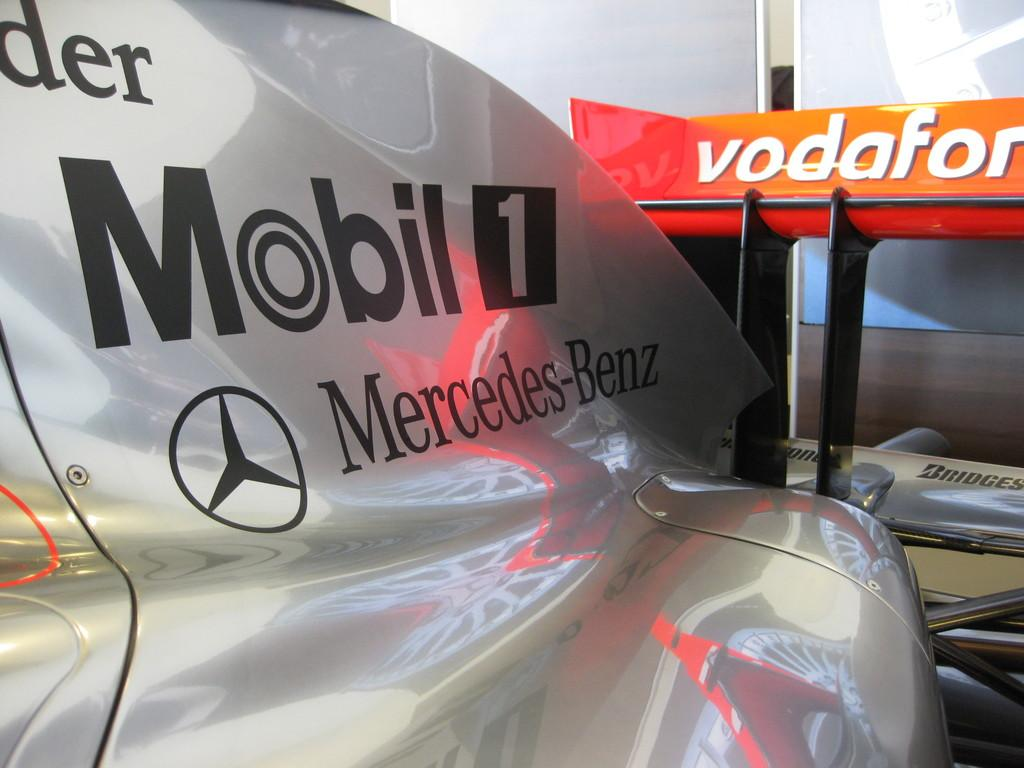What type of vehicle is in the image? There is a sports car in the image. Can you identify the brand of the sports car? The sports car is a Mercedes Benz. What type of farm animals can be seen in the image? There are no farm animals present in the image; it features a sports car. What type of sack is being used to carry the birds in the image? There are no birds or sacks present in the image; it features a sports car. 